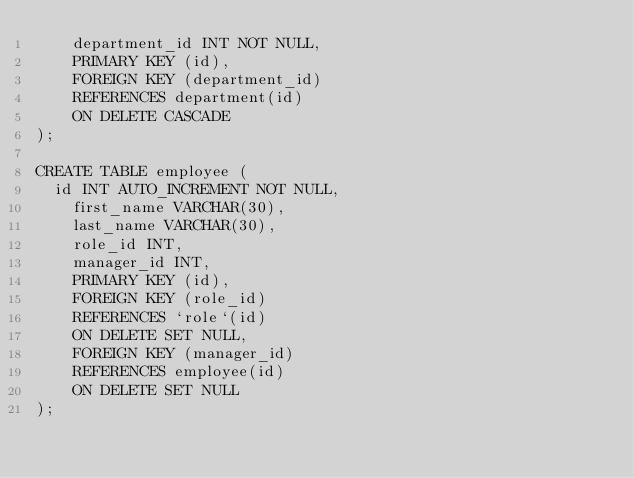<code> <loc_0><loc_0><loc_500><loc_500><_SQL_>    department_id INT NOT NULL,
    PRIMARY KEY (id),
    FOREIGN KEY (department_id)
    REFERENCES department(id)
    ON DELETE CASCADE
);

CREATE TABLE employee (
	id INT AUTO_INCREMENT NOT NULL,
    first_name VARCHAR(30),
    last_name VARCHAR(30),
    role_id INT,
    manager_id INT,
    PRIMARY KEY (id),
    FOREIGN KEY (role_id)
    REFERENCES `role`(id)
    ON DELETE SET NULL,
    FOREIGN KEY (manager_id)
    REFERENCES employee(id)
    ON DELETE SET NULL
);</code> 